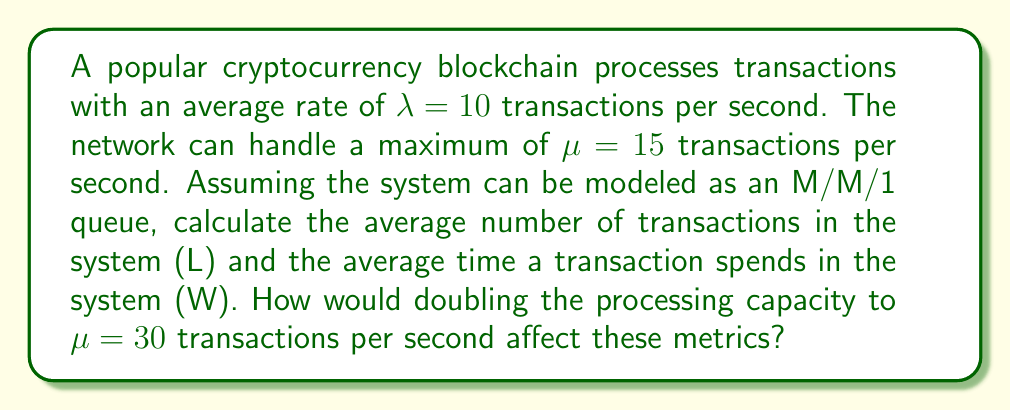Help me with this question. To solve this problem, we'll use queueing theory, specifically the M/M/1 queue model, which is often used to analyze blockchain transaction processing.

1. Calculate the utilization factor $\rho$:
   $\rho = \frac{\lambda}{\mu} = \frac{10}{15} = \frac{2}{3}$

2. Calculate the average number of transactions in the system (L):
   $L = \frac{\rho}{1-\rho} = \frac{2/3}{1-2/3} = \frac{2/3}{1/3} = 2$ transactions

3. Calculate the average time a transaction spends in the system (W):
   Using Little's Law: $W = \frac{L}{\lambda} = \frac{2}{10} = 0.2$ seconds

Now, let's consider doubling the processing capacity to $\mu = 30$ transactions per second:

4. New utilization factor $\rho_{new}$:
   $\rho_{new} = \frac{\lambda}{\mu_{new}} = \frac{10}{30} = \frac{1}{3}$

5. New average number of transactions in the system (L_new):
   $L_{new} = \frac{\rho_{new}}{1-\rho_{new}} = \frac{1/3}{1-1/3} = \frac{1/3}{2/3} = 0.5$ transactions

6. New average time a transaction spends in the system (W_new):
   $W_{new} = \frac{L_{new}}{\lambda} = \frac{0.5}{10} = 0.05$ seconds

The impact of doubling the processing capacity:
- L decreased from 2 to 0.5 transactions (75% reduction)
- W decreased from 0.2 to 0.05 seconds (75% reduction)

This demonstrates that increasing blockchain scalability (processing capacity) significantly reduces both the number of pending transactions and the average transaction time, improving overall throughput and user experience.
Answer: Initial metrics: L = 2 transactions, W = 0.2 seconds
After doubling capacity: L_new = 0.5 transactions, W_new = 0.05 seconds
Impact: 75% reduction in both average number of transactions and average transaction time 